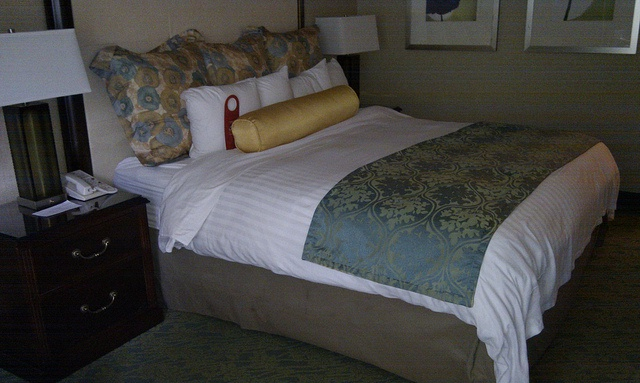Describe the objects in this image and their specific colors. I can see a bed in black, gray, darkgray, and darkgreen tones in this image. 